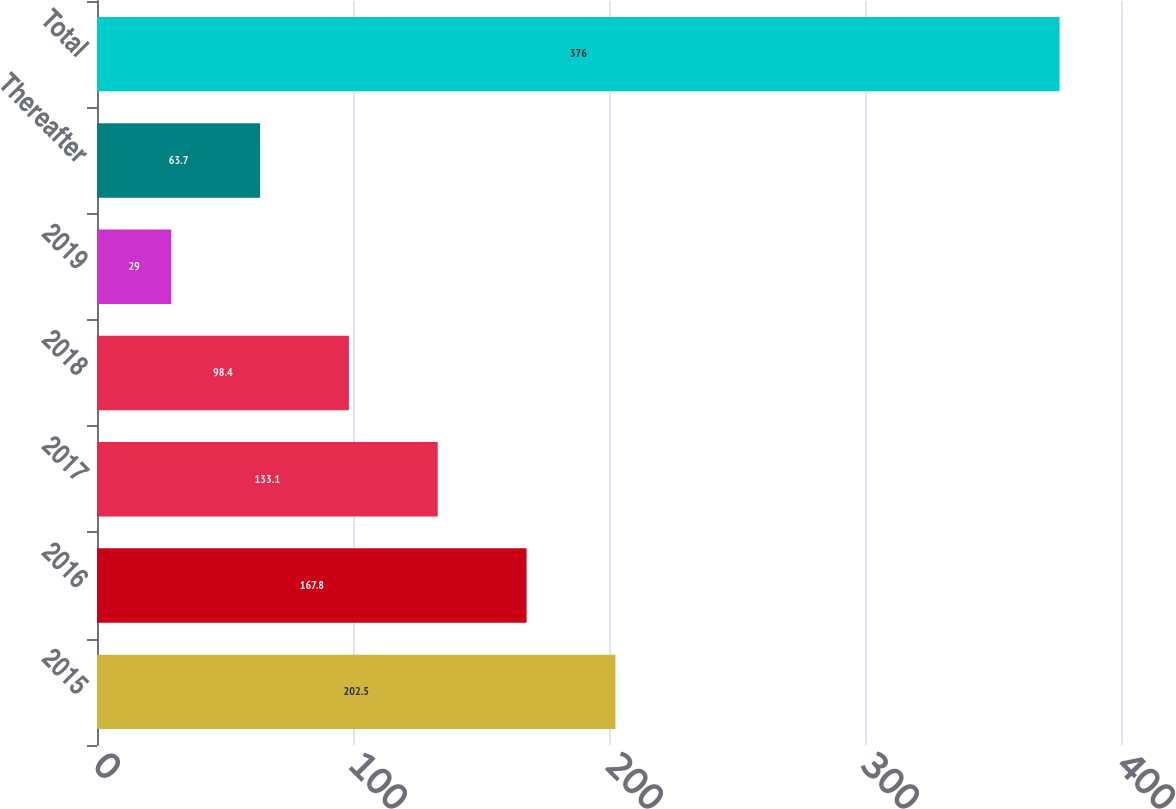<chart> <loc_0><loc_0><loc_500><loc_500><bar_chart><fcel>2015<fcel>2016<fcel>2017<fcel>2018<fcel>2019<fcel>Thereafter<fcel>Total<nl><fcel>202.5<fcel>167.8<fcel>133.1<fcel>98.4<fcel>29<fcel>63.7<fcel>376<nl></chart> 